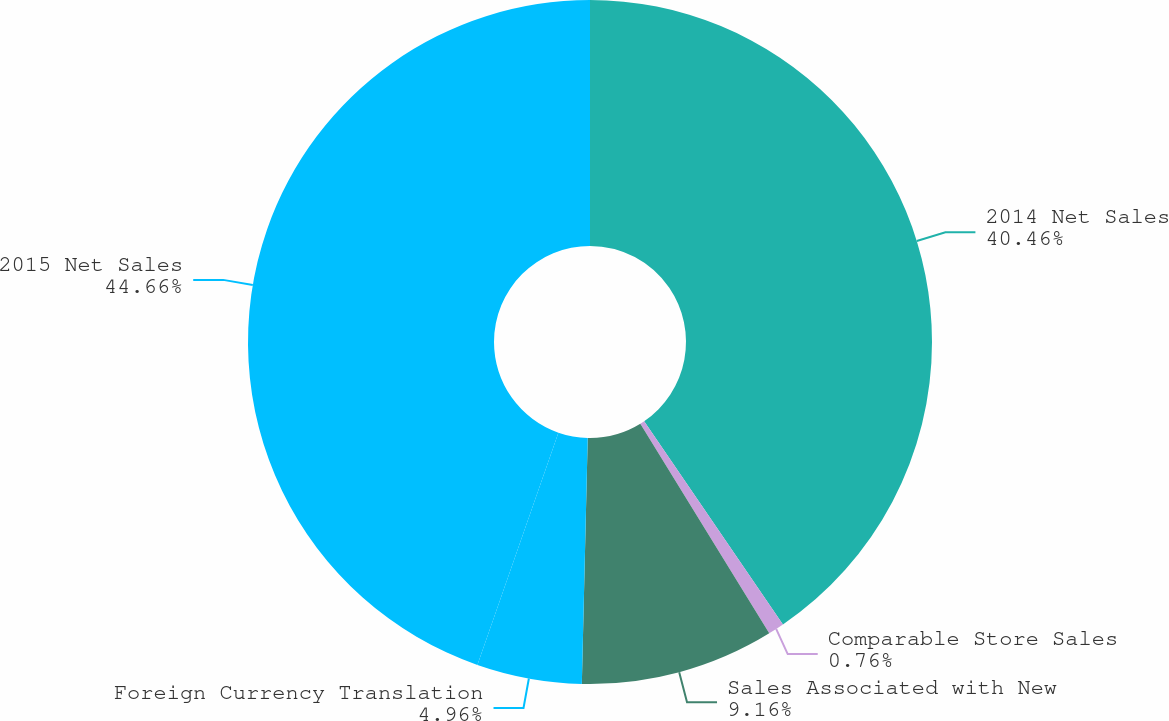Convert chart. <chart><loc_0><loc_0><loc_500><loc_500><pie_chart><fcel>2014 Net Sales<fcel>Comparable Store Sales<fcel>Sales Associated with New<fcel>Foreign Currency Translation<fcel>2015 Net Sales<nl><fcel>40.46%<fcel>0.76%<fcel>9.16%<fcel>4.96%<fcel>44.66%<nl></chart> 